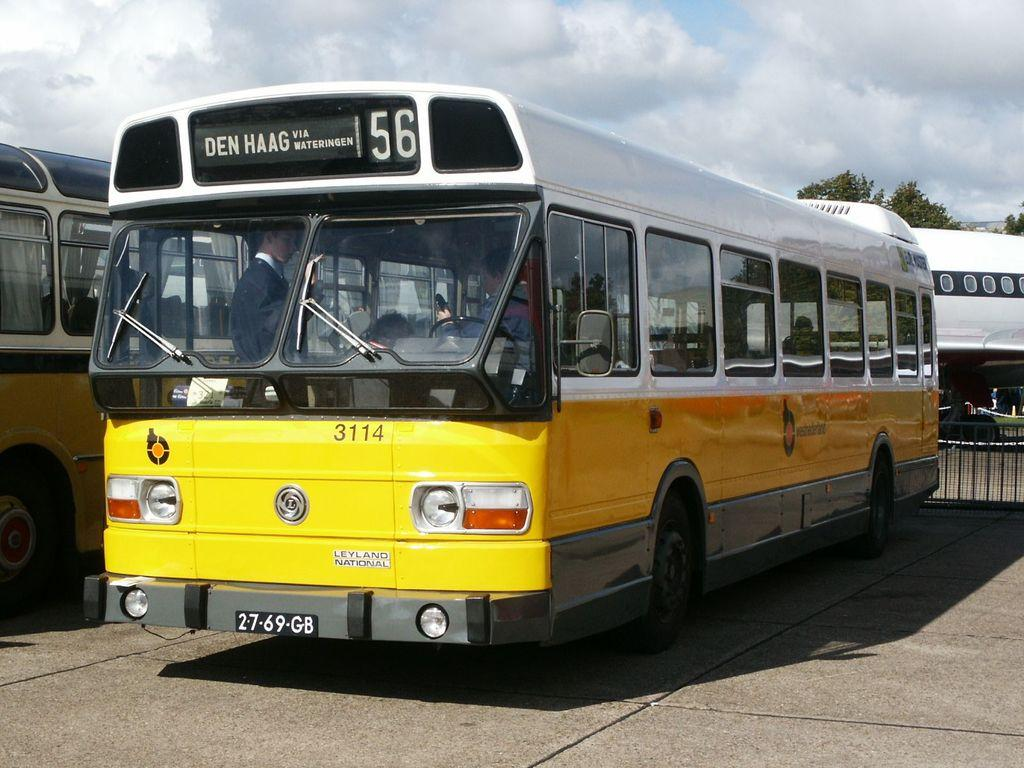What type of vehicles are on the road in the image? There are two buses on the road in the image. Where are the buses located in the image? The buses are on the left side of the image. Can you describe the passengers in one of the buses? There are persons in one of the buses. What can be seen in the background of the image? There are trees, an aircraft, and a fence in the background of the image. What is visible in the sky in the image? There are clouds in the sky. What type of pet is sitting next to the driver in the bus? There is no pet visible in the image; only the buses and passengers are present. 